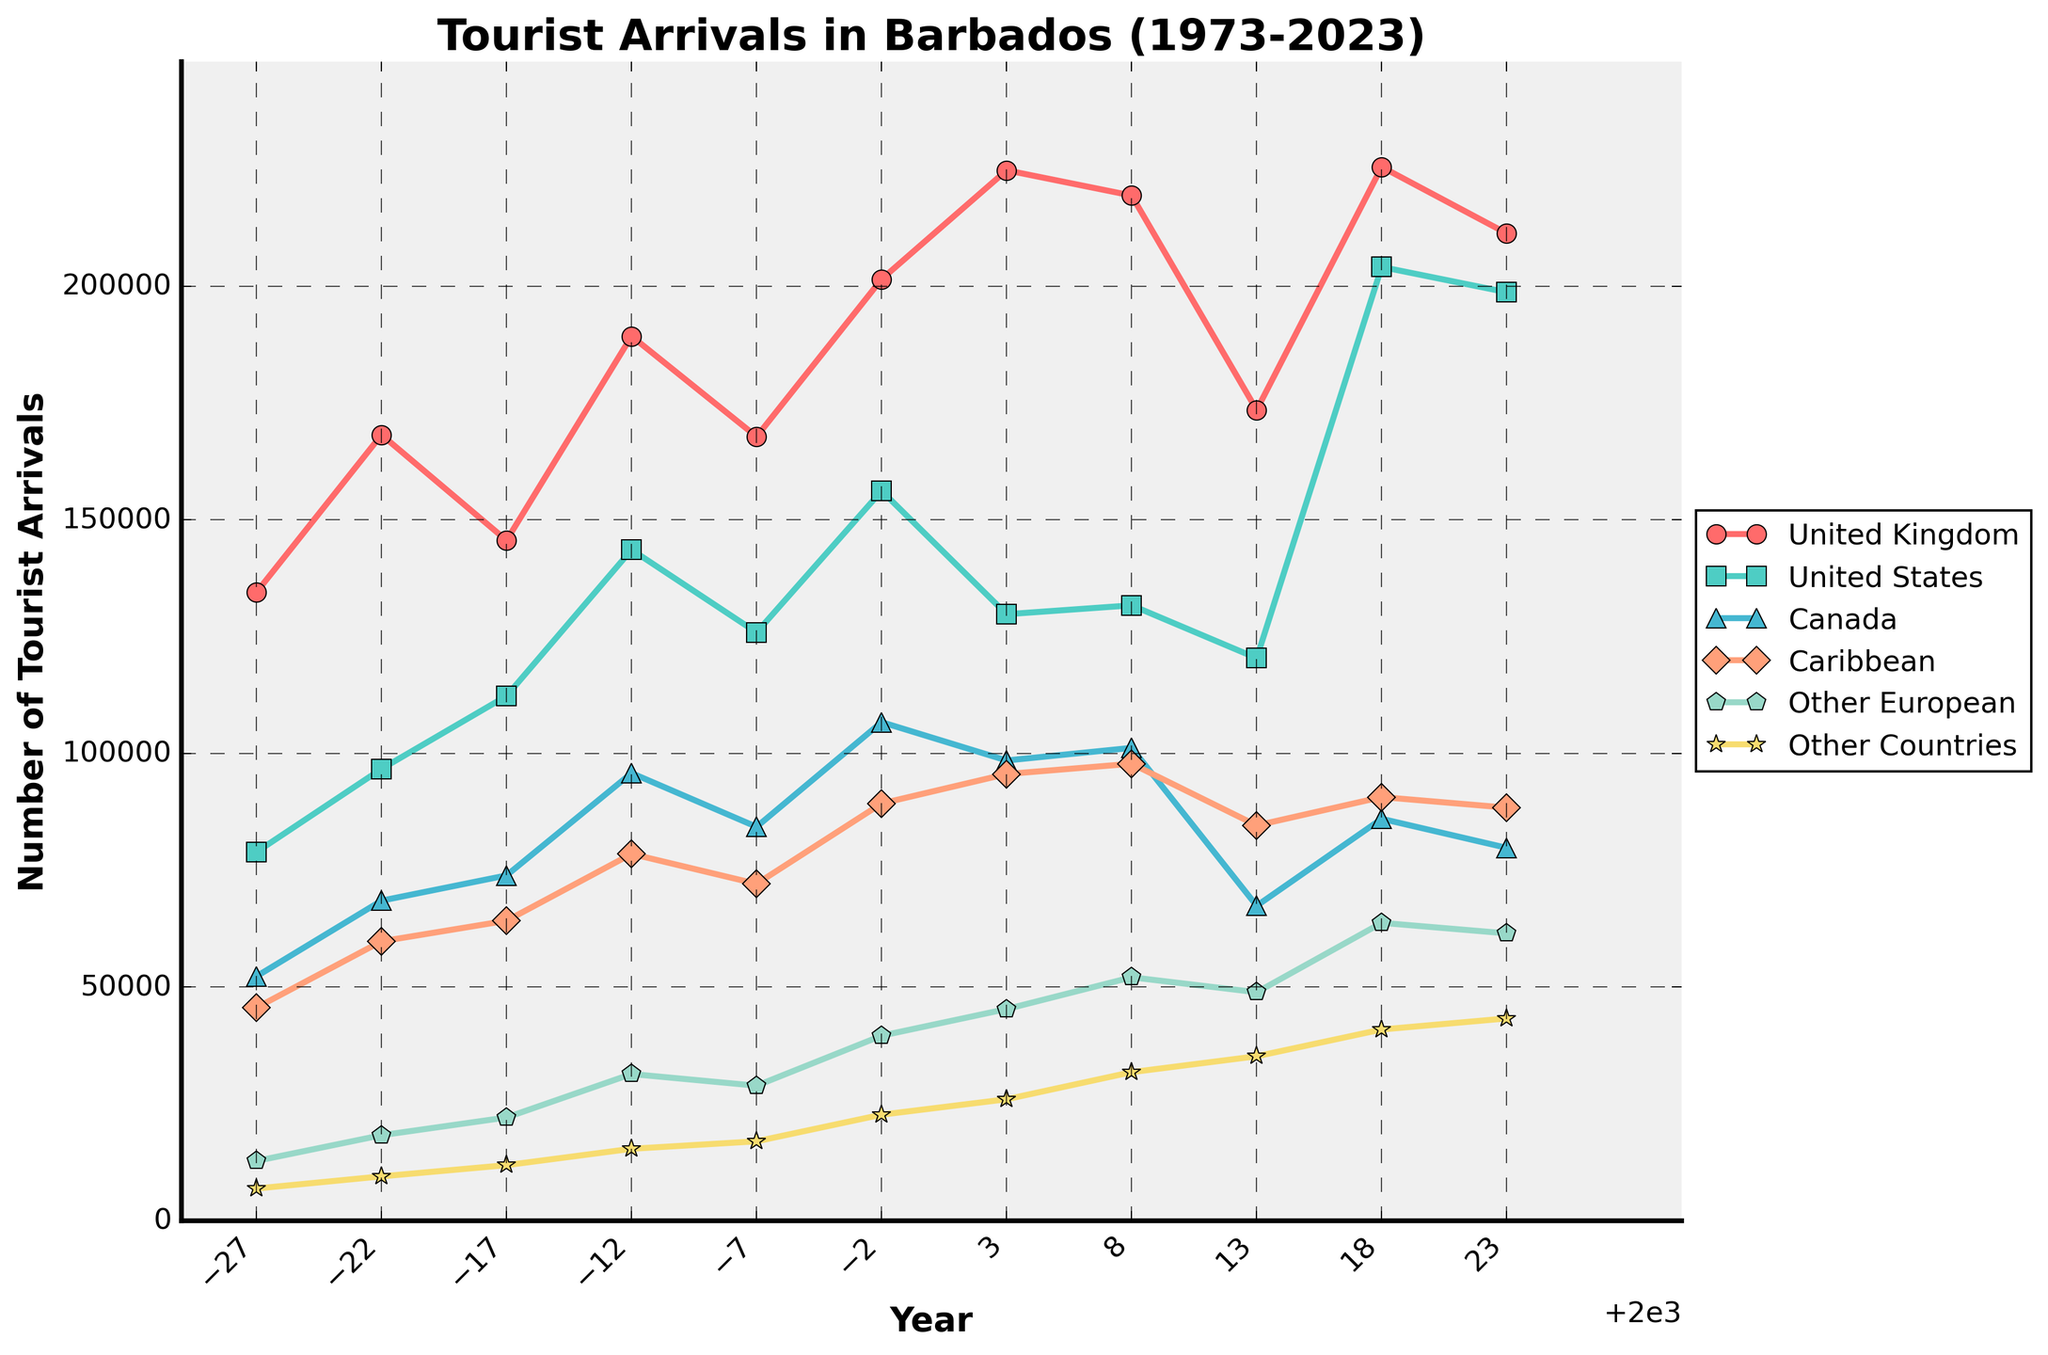Which country had the highest number of tourist arrivals in 2018? By examining the plot for the year 2018, identify the country with the highest point on the y-axis. The line representing the United States reaches the highest number of tourist arrivals in 2018.
Answer: United States In which year did tourist arrivals from Canada surpass those from the Caribbean? Look at the lines representing Canada and the Caribbean over the years. Around 2003, the line for Canada is above the line for the Caribbean, showing that tourist arrivals from Canada surpassed those from the Caribbean.
Answer: 2003 What is the overall trend in tourist arrivals from the United Kingdom over the 50 years? Observe the line for the United Kingdom from 1973 to 2023. The line generally trends upward, indicating an overall increase in tourist arrivals from the United Kingdom.
Answer: Increasing Comparing 1973 and 2023, how much have tourist arrivals from the United States increased? Find the tourist arrivals for the United States in 1973 and 2023. The values are 78,900 in 1973 and 198,700 in 2023. Subtract the smaller value from the larger one: 198,700 - 78,900 = 119,800.
Answer: 119,800 Among the countries listed, which has shown the most consistent growth in tourist arrivals over the years? Identify the country with the smoothest and steadily increasing line over the years. The line for the United Kingdom shows the most consistent growth compared to the other countries.
Answer: United Kingdom What was the total number of tourist arrivals from all countries in the year 1988? Add the tourist arrivals from all the listed countries in 1988: 189,300 (UK) + 143,600 (US) + 95,800 (Canada) + 78,500 (Caribbean) + 31,400 (Other European) + 15,400 (Other Countries) = 553,000.
Answer: 553,000 How did the number of tourist arrivals from Other European countries change between 1998 and 2023? Compare the values in 1998 and 2023 for Other European countries. In 1998, the value was 39,600, and in 2023, it was 61,500. The change is 61,500 - 39,600 = 21,900.
Answer: Increased by 21,900 In which decade did tourist arrivals from the Caribbean see the most significant increase? Look at the line representing the Caribbean and identify the decade with the steepest increase. The largest increase is seen between 1983 and 1988.
Answer: 1980s Which country had the least tourist arrivals in 1973, and how many were there? Identify the country with the lowest point on the y-axis in 1973. For 1973, the country with the least arrivals is Other Countries, with 6,900 tourists.
Answer: Other Countries, 6,900 